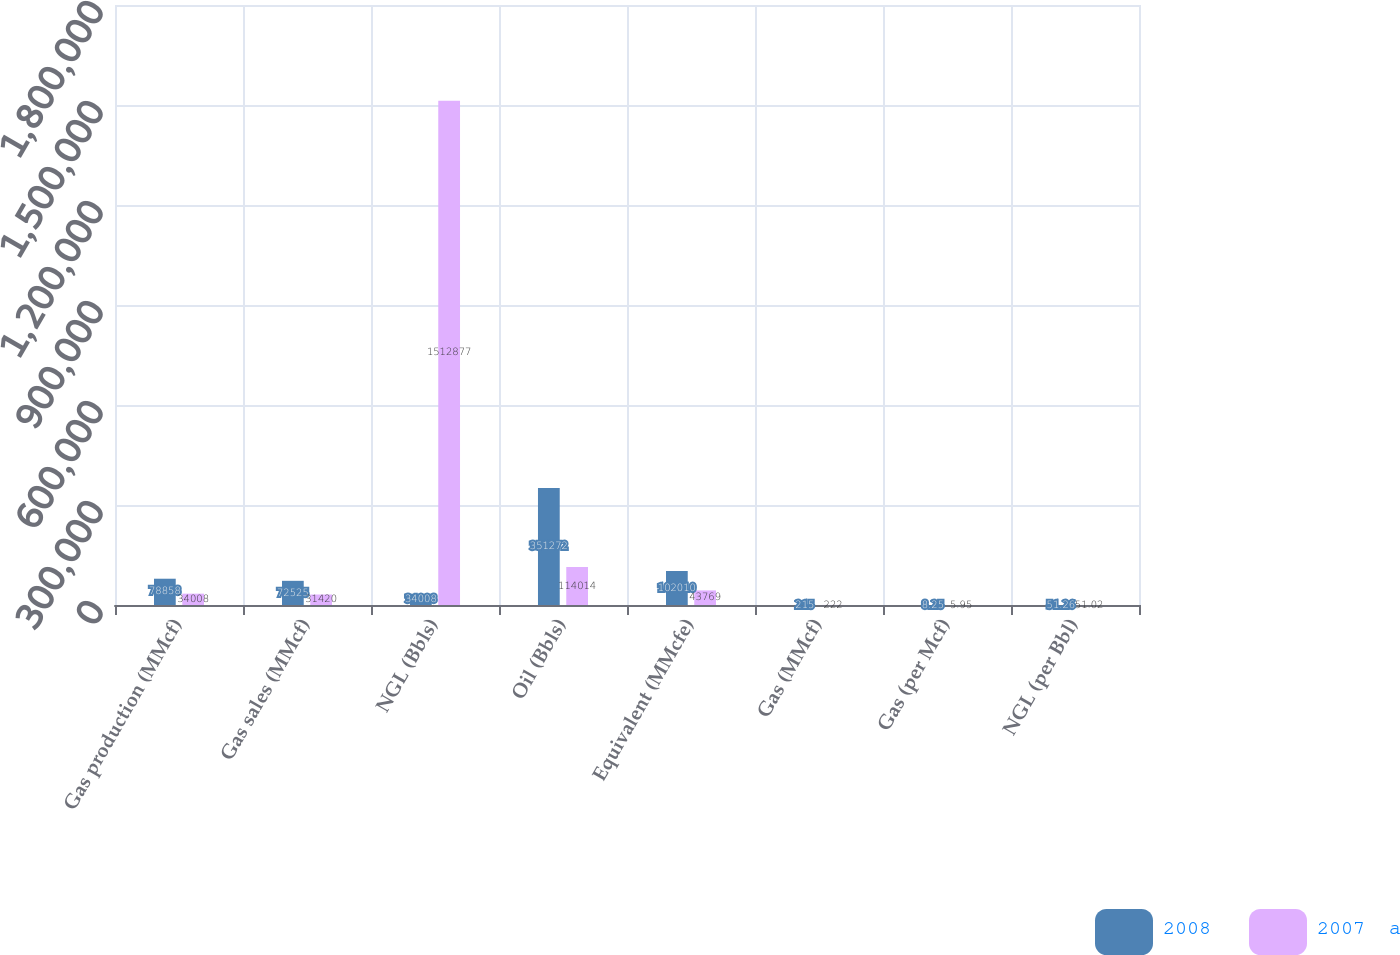Convert chart. <chart><loc_0><loc_0><loc_500><loc_500><stacked_bar_chart><ecel><fcel>Gas production (MMcf)<fcel>Gas sales (MMcf)<fcel>NGL (Bbls)<fcel>Oil (Bbls)<fcel>Equivalent (MMcfe)<fcel>Gas (MMcf)<fcel>Gas (per Mcf)<fcel>NGL (per Bbl)<nl><fcel>2008<fcel>78858<fcel>72525<fcel>34008<fcel>351272<fcel>102010<fcel>215<fcel>8.25<fcel>51.26<nl><fcel>2007  a<fcel>34008<fcel>31420<fcel>1.51288e+06<fcel>114014<fcel>43769<fcel>222<fcel>5.95<fcel>51.02<nl></chart> 